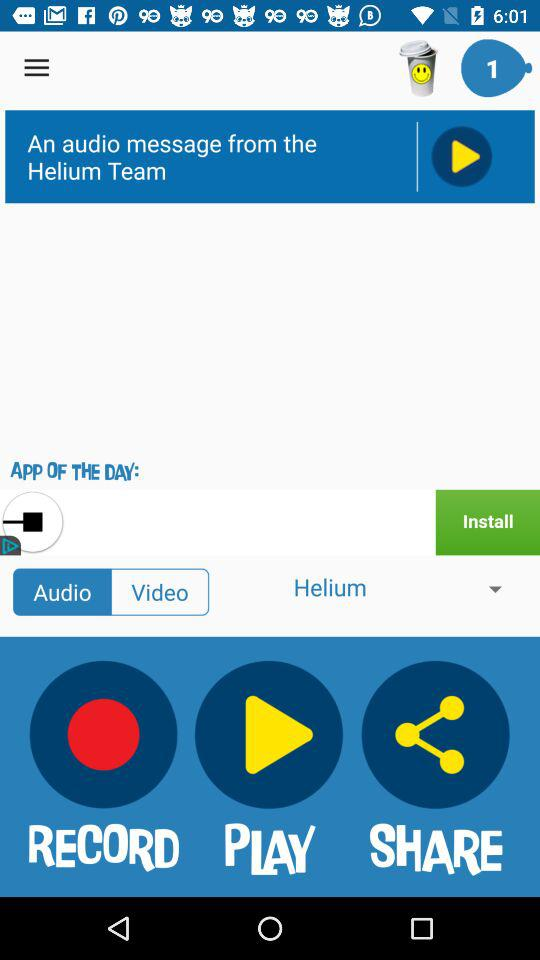What is the name of the application?
When the provided information is insufficient, respond with <no answer>. <no answer> 